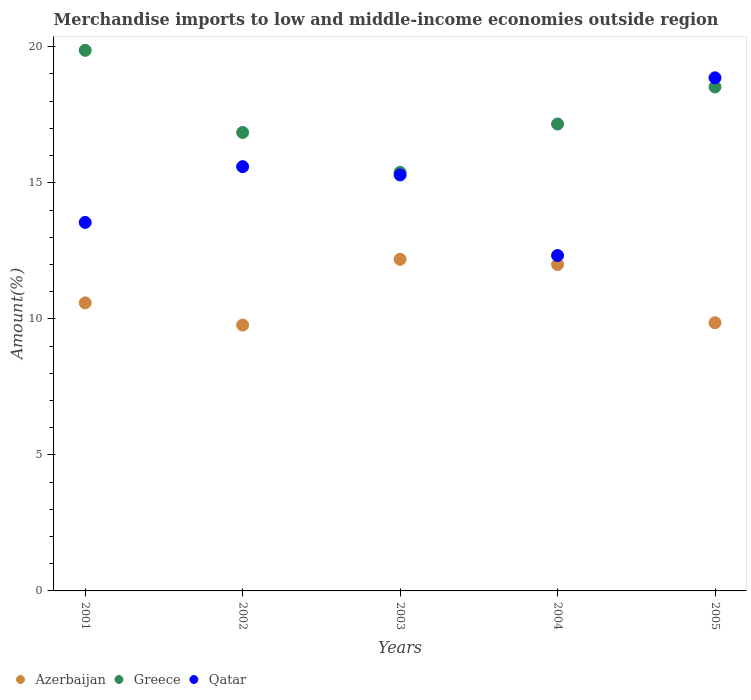How many different coloured dotlines are there?
Your response must be concise. 3. Is the number of dotlines equal to the number of legend labels?
Your response must be concise. Yes. What is the percentage of amount earned from merchandise imports in Qatar in 2002?
Your answer should be very brief. 15.59. Across all years, what is the maximum percentage of amount earned from merchandise imports in Greece?
Offer a terse response. 19.87. Across all years, what is the minimum percentage of amount earned from merchandise imports in Greece?
Give a very brief answer. 15.38. In which year was the percentage of amount earned from merchandise imports in Qatar maximum?
Offer a terse response. 2005. What is the total percentage of amount earned from merchandise imports in Qatar in the graph?
Provide a succinct answer. 75.61. What is the difference between the percentage of amount earned from merchandise imports in Qatar in 2002 and that in 2005?
Keep it short and to the point. -3.27. What is the difference between the percentage of amount earned from merchandise imports in Azerbaijan in 2004 and the percentage of amount earned from merchandise imports in Qatar in 2003?
Make the answer very short. -3.29. What is the average percentage of amount earned from merchandise imports in Azerbaijan per year?
Provide a short and direct response. 10.88. In the year 2005, what is the difference between the percentage of amount earned from merchandise imports in Qatar and percentage of amount earned from merchandise imports in Greece?
Provide a short and direct response. 0.34. What is the ratio of the percentage of amount earned from merchandise imports in Greece in 2001 to that in 2005?
Give a very brief answer. 1.07. Is the percentage of amount earned from merchandise imports in Azerbaijan in 2001 less than that in 2004?
Your response must be concise. Yes. Is the difference between the percentage of amount earned from merchandise imports in Qatar in 2001 and 2003 greater than the difference between the percentage of amount earned from merchandise imports in Greece in 2001 and 2003?
Your answer should be very brief. No. What is the difference between the highest and the second highest percentage of amount earned from merchandise imports in Azerbaijan?
Offer a very short reply. 0.19. What is the difference between the highest and the lowest percentage of amount earned from merchandise imports in Greece?
Your answer should be compact. 4.49. In how many years, is the percentage of amount earned from merchandise imports in Qatar greater than the average percentage of amount earned from merchandise imports in Qatar taken over all years?
Give a very brief answer. 3. How many dotlines are there?
Keep it short and to the point. 3. How many years are there in the graph?
Keep it short and to the point. 5. Does the graph contain grids?
Keep it short and to the point. No. How many legend labels are there?
Ensure brevity in your answer.  3. What is the title of the graph?
Ensure brevity in your answer.  Merchandise imports to low and middle-income economies outside region. What is the label or title of the X-axis?
Keep it short and to the point. Years. What is the label or title of the Y-axis?
Your answer should be very brief. Amount(%). What is the Amount(%) in Azerbaijan in 2001?
Your answer should be compact. 10.59. What is the Amount(%) of Greece in 2001?
Your answer should be compact. 19.87. What is the Amount(%) of Qatar in 2001?
Your answer should be very brief. 13.54. What is the Amount(%) of Azerbaijan in 2002?
Ensure brevity in your answer.  9.77. What is the Amount(%) of Greece in 2002?
Offer a terse response. 16.85. What is the Amount(%) in Qatar in 2002?
Give a very brief answer. 15.59. What is the Amount(%) of Azerbaijan in 2003?
Give a very brief answer. 12.19. What is the Amount(%) of Greece in 2003?
Offer a terse response. 15.38. What is the Amount(%) in Qatar in 2003?
Make the answer very short. 15.29. What is the Amount(%) in Azerbaijan in 2004?
Offer a terse response. 12. What is the Amount(%) in Greece in 2004?
Provide a short and direct response. 17.16. What is the Amount(%) in Qatar in 2004?
Your response must be concise. 12.33. What is the Amount(%) in Azerbaijan in 2005?
Keep it short and to the point. 9.86. What is the Amount(%) of Greece in 2005?
Offer a very short reply. 18.52. What is the Amount(%) of Qatar in 2005?
Your response must be concise. 18.86. Across all years, what is the maximum Amount(%) of Azerbaijan?
Give a very brief answer. 12.19. Across all years, what is the maximum Amount(%) of Greece?
Your answer should be very brief. 19.87. Across all years, what is the maximum Amount(%) in Qatar?
Offer a very short reply. 18.86. Across all years, what is the minimum Amount(%) in Azerbaijan?
Give a very brief answer. 9.77. Across all years, what is the minimum Amount(%) of Greece?
Your answer should be very brief. 15.38. Across all years, what is the minimum Amount(%) of Qatar?
Give a very brief answer. 12.33. What is the total Amount(%) in Azerbaijan in the graph?
Make the answer very short. 54.4. What is the total Amount(%) in Greece in the graph?
Keep it short and to the point. 87.79. What is the total Amount(%) in Qatar in the graph?
Provide a succinct answer. 75.61. What is the difference between the Amount(%) in Azerbaijan in 2001 and that in 2002?
Keep it short and to the point. 0.82. What is the difference between the Amount(%) in Greece in 2001 and that in 2002?
Provide a succinct answer. 3.02. What is the difference between the Amount(%) in Qatar in 2001 and that in 2002?
Provide a succinct answer. -2.05. What is the difference between the Amount(%) of Azerbaijan in 2001 and that in 2003?
Offer a very short reply. -1.6. What is the difference between the Amount(%) of Greece in 2001 and that in 2003?
Provide a succinct answer. 4.49. What is the difference between the Amount(%) of Qatar in 2001 and that in 2003?
Offer a terse response. -1.75. What is the difference between the Amount(%) in Azerbaijan in 2001 and that in 2004?
Provide a succinct answer. -1.41. What is the difference between the Amount(%) of Greece in 2001 and that in 2004?
Your response must be concise. 2.71. What is the difference between the Amount(%) in Qatar in 2001 and that in 2004?
Provide a short and direct response. 1.22. What is the difference between the Amount(%) in Azerbaijan in 2001 and that in 2005?
Your response must be concise. 0.73. What is the difference between the Amount(%) in Greece in 2001 and that in 2005?
Provide a short and direct response. 1.35. What is the difference between the Amount(%) in Qatar in 2001 and that in 2005?
Provide a succinct answer. -5.32. What is the difference between the Amount(%) in Azerbaijan in 2002 and that in 2003?
Provide a short and direct response. -2.42. What is the difference between the Amount(%) of Greece in 2002 and that in 2003?
Make the answer very short. 1.47. What is the difference between the Amount(%) in Qatar in 2002 and that in 2003?
Give a very brief answer. 0.3. What is the difference between the Amount(%) in Azerbaijan in 2002 and that in 2004?
Ensure brevity in your answer.  -2.23. What is the difference between the Amount(%) in Greece in 2002 and that in 2004?
Offer a terse response. -0.31. What is the difference between the Amount(%) of Qatar in 2002 and that in 2004?
Provide a short and direct response. 3.27. What is the difference between the Amount(%) of Azerbaijan in 2002 and that in 2005?
Provide a short and direct response. -0.09. What is the difference between the Amount(%) in Greece in 2002 and that in 2005?
Keep it short and to the point. -1.67. What is the difference between the Amount(%) in Qatar in 2002 and that in 2005?
Give a very brief answer. -3.27. What is the difference between the Amount(%) of Azerbaijan in 2003 and that in 2004?
Keep it short and to the point. 0.19. What is the difference between the Amount(%) in Greece in 2003 and that in 2004?
Keep it short and to the point. -1.78. What is the difference between the Amount(%) of Qatar in 2003 and that in 2004?
Provide a succinct answer. 2.96. What is the difference between the Amount(%) of Azerbaijan in 2003 and that in 2005?
Provide a succinct answer. 2.33. What is the difference between the Amount(%) in Greece in 2003 and that in 2005?
Keep it short and to the point. -3.14. What is the difference between the Amount(%) of Qatar in 2003 and that in 2005?
Provide a short and direct response. -3.57. What is the difference between the Amount(%) of Azerbaijan in 2004 and that in 2005?
Provide a short and direct response. 2.14. What is the difference between the Amount(%) in Greece in 2004 and that in 2005?
Your answer should be compact. -1.36. What is the difference between the Amount(%) in Qatar in 2004 and that in 2005?
Ensure brevity in your answer.  -6.53. What is the difference between the Amount(%) in Azerbaijan in 2001 and the Amount(%) in Greece in 2002?
Ensure brevity in your answer.  -6.26. What is the difference between the Amount(%) in Azerbaijan in 2001 and the Amount(%) in Qatar in 2002?
Ensure brevity in your answer.  -5.01. What is the difference between the Amount(%) of Greece in 2001 and the Amount(%) of Qatar in 2002?
Keep it short and to the point. 4.28. What is the difference between the Amount(%) in Azerbaijan in 2001 and the Amount(%) in Greece in 2003?
Give a very brief answer. -4.8. What is the difference between the Amount(%) of Azerbaijan in 2001 and the Amount(%) of Qatar in 2003?
Ensure brevity in your answer.  -4.7. What is the difference between the Amount(%) of Greece in 2001 and the Amount(%) of Qatar in 2003?
Offer a terse response. 4.58. What is the difference between the Amount(%) in Azerbaijan in 2001 and the Amount(%) in Greece in 2004?
Offer a terse response. -6.57. What is the difference between the Amount(%) of Azerbaijan in 2001 and the Amount(%) of Qatar in 2004?
Provide a short and direct response. -1.74. What is the difference between the Amount(%) of Greece in 2001 and the Amount(%) of Qatar in 2004?
Keep it short and to the point. 7.54. What is the difference between the Amount(%) of Azerbaijan in 2001 and the Amount(%) of Greece in 2005?
Offer a very short reply. -7.94. What is the difference between the Amount(%) in Azerbaijan in 2001 and the Amount(%) in Qatar in 2005?
Provide a succinct answer. -8.27. What is the difference between the Amount(%) of Greece in 2001 and the Amount(%) of Qatar in 2005?
Your response must be concise. 1.01. What is the difference between the Amount(%) in Azerbaijan in 2002 and the Amount(%) in Greece in 2003?
Provide a succinct answer. -5.61. What is the difference between the Amount(%) of Azerbaijan in 2002 and the Amount(%) of Qatar in 2003?
Provide a short and direct response. -5.52. What is the difference between the Amount(%) in Greece in 2002 and the Amount(%) in Qatar in 2003?
Your answer should be very brief. 1.56. What is the difference between the Amount(%) in Azerbaijan in 2002 and the Amount(%) in Greece in 2004?
Offer a very short reply. -7.39. What is the difference between the Amount(%) of Azerbaijan in 2002 and the Amount(%) of Qatar in 2004?
Provide a succinct answer. -2.56. What is the difference between the Amount(%) in Greece in 2002 and the Amount(%) in Qatar in 2004?
Your answer should be compact. 4.52. What is the difference between the Amount(%) of Azerbaijan in 2002 and the Amount(%) of Greece in 2005?
Your response must be concise. -8.75. What is the difference between the Amount(%) of Azerbaijan in 2002 and the Amount(%) of Qatar in 2005?
Offer a terse response. -9.09. What is the difference between the Amount(%) in Greece in 2002 and the Amount(%) in Qatar in 2005?
Your response must be concise. -2.01. What is the difference between the Amount(%) in Azerbaijan in 2003 and the Amount(%) in Greece in 2004?
Give a very brief answer. -4.97. What is the difference between the Amount(%) of Azerbaijan in 2003 and the Amount(%) of Qatar in 2004?
Provide a short and direct response. -0.14. What is the difference between the Amount(%) of Greece in 2003 and the Amount(%) of Qatar in 2004?
Give a very brief answer. 3.06. What is the difference between the Amount(%) of Azerbaijan in 2003 and the Amount(%) of Greece in 2005?
Provide a short and direct response. -6.33. What is the difference between the Amount(%) in Azerbaijan in 2003 and the Amount(%) in Qatar in 2005?
Give a very brief answer. -6.67. What is the difference between the Amount(%) of Greece in 2003 and the Amount(%) of Qatar in 2005?
Keep it short and to the point. -3.48. What is the difference between the Amount(%) in Azerbaijan in 2004 and the Amount(%) in Greece in 2005?
Offer a terse response. -6.52. What is the difference between the Amount(%) of Azerbaijan in 2004 and the Amount(%) of Qatar in 2005?
Give a very brief answer. -6.86. What is the difference between the Amount(%) of Greece in 2004 and the Amount(%) of Qatar in 2005?
Your response must be concise. -1.7. What is the average Amount(%) of Azerbaijan per year?
Give a very brief answer. 10.88. What is the average Amount(%) in Greece per year?
Your response must be concise. 17.56. What is the average Amount(%) in Qatar per year?
Offer a very short reply. 15.12. In the year 2001, what is the difference between the Amount(%) in Azerbaijan and Amount(%) in Greece?
Keep it short and to the point. -9.28. In the year 2001, what is the difference between the Amount(%) in Azerbaijan and Amount(%) in Qatar?
Your answer should be compact. -2.96. In the year 2001, what is the difference between the Amount(%) in Greece and Amount(%) in Qatar?
Provide a succinct answer. 6.33. In the year 2002, what is the difference between the Amount(%) of Azerbaijan and Amount(%) of Greece?
Provide a short and direct response. -7.08. In the year 2002, what is the difference between the Amount(%) of Azerbaijan and Amount(%) of Qatar?
Provide a succinct answer. -5.82. In the year 2002, what is the difference between the Amount(%) in Greece and Amount(%) in Qatar?
Keep it short and to the point. 1.26. In the year 2003, what is the difference between the Amount(%) of Azerbaijan and Amount(%) of Greece?
Provide a succinct answer. -3.2. In the year 2003, what is the difference between the Amount(%) of Azerbaijan and Amount(%) of Qatar?
Provide a succinct answer. -3.1. In the year 2003, what is the difference between the Amount(%) of Greece and Amount(%) of Qatar?
Ensure brevity in your answer.  0.09. In the year 2004, what is the difference between the Amount(%) in Azerbaijan and Amount(%) in Greece?
Provide a succinct answer. -5.16. In the year 2004, what is the difference between the Amount(%) of Azerbaijan and Amount(%) of Qatar?
Your answer should be very brief. -0.33. In the year 2004, what is the difference between the Amount(%) in Greece and Amount(%) in Qatar?
Your answer should be compact. 4.83. In the year 2005, what is the difference between the Amount(%) in Azerbaijan and Amount(%) in Greece?
Provide a short and direct response. -8.66. In the year 2005, what is the difference between the Amount(%) in Azerbaijan and Amount(%) in Qatar?
Offer a terse response. -9. In the year 2005, what is the difference between the Amount(%) in Greece and Amount(%) in Qatar?
Offer a very short reply. -0.34. What is the ratio of the Amount(%) in Azerbaijan in 2001 to that in 2002?
Offer a terse response. 1.08. What is the ratio of the Amount(%) in Greece in 2001 to that in 2002?
Keep it short and to the point. 1.18. What is the ratio of the Amount(%) of Qatar in 2001 to that in 2002?
Offer a terse response. 0.87. What is the ratio of the Amount(%) of Azerbaijan in 2001 to that in 2003?
Make the answer very short. 0.87. What is the ratio of the Amount(%) in Greece in 2001 to that in 2003?
Offer a very short reply. 1.29. What is the ratio of the Amount(%) of Qatar in 2001 to that in 2003?
Keep it short and to the point. 0.89. What is the ratio of the Amount(%) in Azerbaijan in 2001 to that in 2004?
Provide a succinct answer. 0.88. What is the ratio of the Amount(%) in Greece in 2001 to that in 2004?
Your answer should be very brief. 1.16. What is the ratio of the Amount(%) of Qatar in 2001 to that in 2004?
Your answer should be very brief. 1.1. What is the ratio of the Amount(%) in Azerbaijan in 2001 to that in 2005?
Give a very brief answer. 1.07. What is the ratio of the Amount(%) of Greece in 2001 to that in 2005?
Your response must be concise. 1.07. What is the ratio of the Amount(%) of Qatar in 2001 to that in 2005?
Your answer should be very brief. 0.72. What is the ratio of the Amount(%) in Azerbaijan in 2002 to that in 2003?
Your response must be concise. 0.8. What is the ratio of the Amount(%) of Greece in 2002 to that in 2003?
Provide a succinct answer. 1.1. What is the ratio of the Amount(%) in Qatar in 2002 to that in 2003?
Give a very brief answer. 1.02. What is the ratio of the Amount(%) of Azerbaijan in 2002 to that in 2004?
Provide a succinct answer. 0.81. What is the ratio of the Amount(%) of Greece in 2002 to that in 2004?
Offer a terse response. 0.98. What is the ratio of the Amount(%) of Qatar in 2002 to that in 2004?
Ensure brevity in your answer.  1.26. What is the ratio of the Amount(%) in Greece in 2002 to that in 2005?
Your answer should be compact. 0.91. What is the ratio of the Amount(%) of Qatar in 2002 to that in 2005?
Your response must be concise. 0.83. What is the ratio of the Amount(%) in Azerbaijan in 2003 to that in 2004?
Your answer should be very brief. 1.02. What is the ratio of the Amount(%) in Greece in 2003 to that in 2004?
Offer a very short reply. 0.9. What is the ratio of the Amount(%) in Qatar in 2003 to that in 2004?
Make the answer very short. 1.24. What is the ratio of the Amount(%) of Azerbaijan in 2003 to that in 2005?
Offer a terse response. 1.24. What is the ratio of the Amount(%) in Greece in 2003 to that in 2005?
Provide a succinct answer. 0.83. What is the ratio of the Amount(%) in Qatar in 2003 to that in 2005?
Your answer should be very brief. 0.81. What is the ratio of the Amount(%) of Azerbaijan in 2004 to that in 2005?
Provide a short and direct response. 1.22. What is the ratio of the Amount(%) in Greece in 2004 to that in 2005?
Offer a very short reply. 0.93. What is the ratio of the Amount(%) of Qatar in 2004 to that in 2005?
Your answer should be very brief. 0.65. What is the difference between the highest and the second highest Amount(%) in Azerbaijan?
Give a very brief answer. 0.19. What is the difference between the highest and the second highest Amount(%) in Greece?
Keep it short and to the point. 1.35. What is the difference between the highest and the second highest Amount(%) of Qatar?
Your response must be concise. 3.27. What is the difference between the highest and the lowest Amount(%) of Azerbaijan?
Give a very brief answer. 2.42. What is the difference between the highest and the lowest Amount(%) of Greece?
Offer a terse response. 4.49. What is the difference between the highest and the lowest Amount(%) in Qatar?
Make the answer very short. 6.53. 